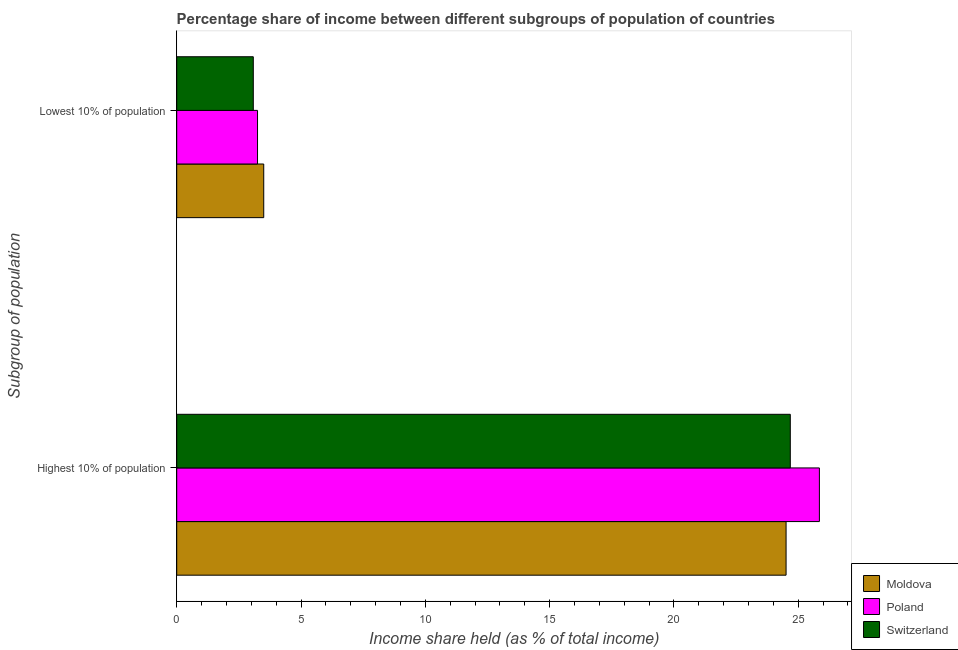How many different coloured bars are there?
Keep it short and to the point. 3. Are the number of bars on each tick of the Y-axis equal?
Make the answer very short. Yes. What is the label of the 1st group of bars from the top?
Offer a very short reply. Lowest 10% of population. What is the income share held by lowest 10% of the population in Switzerland?
Give a very brief answer. 3.08. Across all countries, what is the minimum income share held by highest 10% of the population?
Offer a very short reply. 24.51. In which country was the income share held by highest 10% of the population maximum?
Offer a terse response. Poland. In which country was the income share held by lowest 10% of the population minimum?
Provide a succinct answer. Switzerland. What is the total income share held by lowest 10% of the population in the graph?
Make the answer very short. 9.83. What is the difference between the income share held by highest 10% of the population in Switzerland and that in Moldova?
Your answer should be compact. 0.17. What is the difference between the income share held by lowest 10% of the population in Switzerland and the income share held by highest 10% of the population in Moldova?
Provide a short and direct response. -21.43. What is the average income share held by highest 10% of the population per country?
Make the answer very short. 25.01. What is the difference between the income share held by highest 10% of the population and income share held by lowest 10% of the population in Poland?
Your response must be concise. 22.6. In how many countries, is the income share held by highest 10% of the population greater than 14 %?
Ensure brevity in your answer.  3. What is the ratio of the income share held by highest 10% of the population in Moldova to that in Switzerland?
Ensure brevity in your answer.  0.99. Is the income share held by highest 10% of the population in Poland less than that in Moldova?
Make the answer very short. No. In how many countries, is the income share held by lowest 10% of the population greater than the average income share held by lowest 10% of the population taken over all countries?
Keep it short and to the point. 1. What does the 2nd bar from the top in Lowest 10% of population represents?
Provide a succinct answer. Poland. How many countries are there in the graph?
Offer a very short reply. 3. What is the difference between two consecutive major ticks on the X-axis?
Make the answer very short. 5. Does the graph contain any zero values?
Provide a succinct answer. No. Does the graph contain grids?
Your answer should be very brief. No. How are the legend labels stacked?
Offer a terse response. Vertical. What is the title of the graph?
Offer a terse response. Percentage share of income between different subgroups of population of countries. Does "Greenland" appear as one of the legend labels in the graph?
Keep it short and to the point. No. What is the label or title of the X-axis?
Your answer should be very brief. Income share held (as % of total income). What is the label or title of the Y-axis?
Give a very brief answer. Subgroup of population. What is the Income share held (as % of total income) in Moldova in Highest 10% of population?
Ensure brevity in your answer.  24.51. What is the Income share held (as % of total income) in Poland in Highest 10% of population?
Your response must be concise. 25.85. What is the Income share held (as % of total income) of Switzerland in Highest 10% of population?
Make the answer very short. 24.68. What is the Income share held (as % of total income) in Moldova in Lowest 10% of population?
Your answer should be very brief. 3.5. What is the Income share held (as % of total income) in Poland in Lowest 10% of population?
Keep it short and to the point. 3.25. What is the Income share held (as % of total income) of Switzerland in Lowest 10% of population?
Offer a very short reply. 3.08. Across all Subgroup of population, what is the maximum Income share held (as % of total income) in Moldova?
Give a very brief answer. 24.51. Across all Subgroup of population, what is the maximum Income share held (as % of total income) in Poland?
Provide a short and direct response. 25.85. Across all Subgroup of population, what is the maximum Income share held (as % of total income) of Switzerland?
Provide a succinct answer. 24.68. Across all Subgroup of population, what is the minimum Income share held (as % of total income) of Poland?
Offer a very short reply. 3.25. Across all Subgroup of population, what is the minimum Income share held (as % of total income) of Switzerland?
Offer a very short reply. 3.08. What is the total Income share held (as % of total income) in Moldova in the graph?
Provide a short and direct response. 28.01. What is the total Income share held (as % of total income) in Poland in the graph?
Ensure brevity in your answer.  29.1. What is the total Income share held (as % of total income) of Switzerland in the graph?
Your answer should be very brief. 27.76. What is the difference between the Income share held (as % of total income) in Moldova in Highest 10% of population and that in Lowest 10% of population?
Your response must be concise. 21.01. What is the difference between the Income share held (as % of total income) of Poland in Highest 10% of population and that in Lowest 10% of population?
Your response must be concise. 22.6. What is the difference between the Income share held (as % of total income) in Switzerland in Highest 10% of population and that in Lowest 10% of population?
Your response must be concise. 21.6. What is the difference between the Income share held (as % of total income) in Moldova in Highest 10% of population and the Income share held (as % of total income) in Poland in Lowest 10% of population?
Give a very brief answer. 21.26. What is the difference between the Income share held (as % of total income) of Moldova in Highest 10% of population and the Income share held (as % of total income) of Switzerland in Lowest 10% of population?
Give a very brief answer. 21.43. What is the difference between the Income share held (as % of total income) in Poland in Highest 10% of population and the Income share held (as % of total income) in Switzerland in Lowest 10% of population?
Provide a succinct answer. 22.77. What is the average Income share held (as % of total income) of Moldova per Subgroup of population?
Your response must be concise. 14.01. What is the average Income share held (as % of total income) of Poland per Subgroup of population?
Keep it short and to the point. 14.55. What is the average Income share held (as % of total income) in Switzerland per Subgroup of population?
Offer a very short reply. 13.88. What is the difference between the Income share held (as % of total income) in Moldova and Income share held (as % of total income) in Poland in Highest 10% of population?
Make the answer very short. -1.34. What is the difference between the Income share held (as % of total income) in Moldova and Income share held (as % of total income) in Switzerland in Highest 10% of population?
Make the answer very short. -0.17. What is the difference between the Income share held (as % of total income) in Poland and Income share held (as % of total income) in Switzerland in Highest 10% of population?
Your answer should be very brief. 1.17. What is the difference between the Income share held (as % of total income) in Moldova and Income share held (as % of total income) in Poland in Lowest 10% of population?
Your answer should be compact. 0.25. What is the difference between the Income share held (as % of total income) in Moldova and Income share held (as % of total income) in Switzerland in Lowest 10% of population?
Make the answer very short. 0.42. What is the difference between the Income share held (as % of total income) in Poland and Income share held (as % of total income) in Switzerland in Lowest 10% of population?
Offer a terse response. 0.17. What is the ratio of the Income share held (as % of total income) in Moldova in Highest 10% of population to that in Lowest 10% of population?
Ensure brevity in your answer.  7. What is the ratio of the Income share held (as % of total income) of Poland in Highest 10% of population to that in Lowest 10% of population?
Keep it short and to the point. 7.95. What is the ratio of the Income share held (as % of total income) of Switzerland in Highest 10% of population to that in Lowest 10% of population?
Your answer should be compact. 8.01. What is the difference between the highest and the second highest Income share held (as % of total income) of Moldova?
Provide a short and direct response. 21.01. What is the difference between the highest and the second highest Income share held (as % of total income) in Poland?
Make the answer very short. 22.6. What is the difference between the highest and the second highest Income share held (as % of total income) of Switzerland?
Ensure brevity in your answer.  21.6. What is the difference between the highest and the lowest Income share held (as % of total income) in Moldova?
Provide a succinct answer. 21.01. What is the difference between the highest and the lowest Income share held (as % of total income) in Poland?
Ensure brevity in your answer.  22.6. What is the difference between the highest and the lowest Income share held (as % of total income) of Switzerland?
Ensure brevity in your answer.  21.6. 